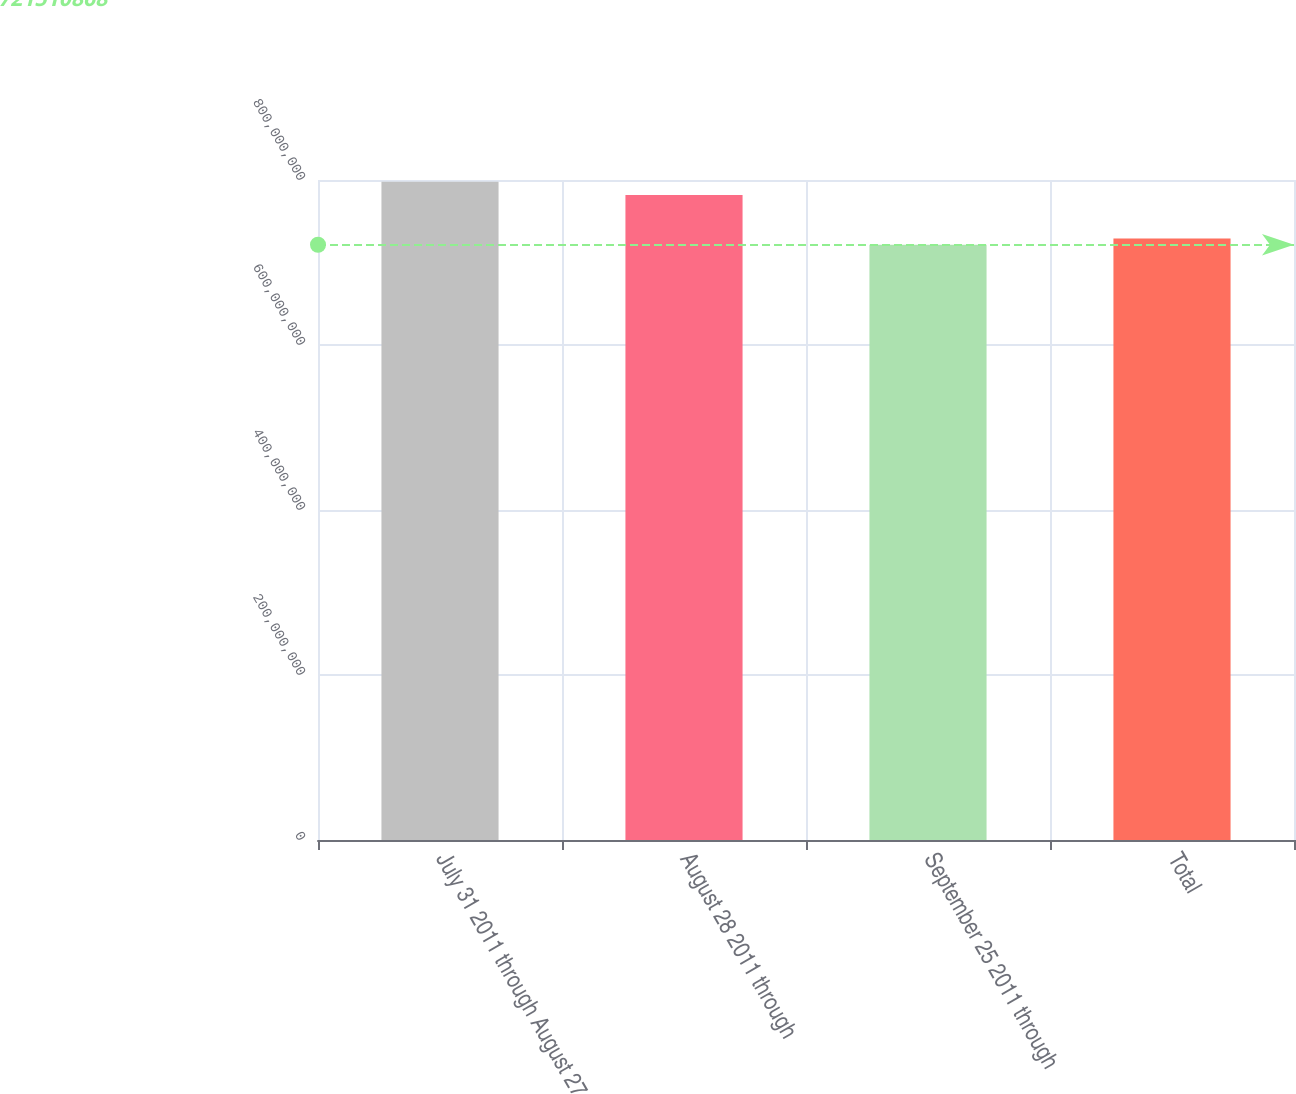Convert chart. <chart><loc_0><loc_0><loc_500><loc_500><bar_chart><fcel>July 31 2011 through August 27<fcel>August 28 2011 through<fcel>September 25 2011 through<fcel>Total<nl><fcel>7.97795e+08<fcel>7.81929e+08<fcel>7.21511e+08<fcel>7.29139e+08<nl></chart> 